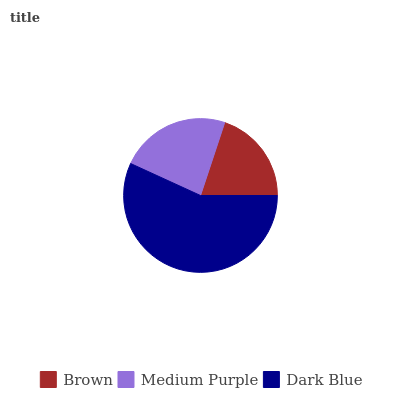Is Brown the minimum?
Answer yes or no. Yes. Is Dark Blue the maximum?
Answer yes or no. Yes. Is Medium Purple the minimum?
Answer yes or no. No. Is Medium Purple the maximum?
Answer yes or no. No. Is Medium Purple greater than Brown?
Answer yes or no. Yes. Is Brown less than Medium Purple?
Answer yes or no. Yes. Is Brown greater than Medium Purple?
Answer yes or no. No. Is Medium Purple less than Brown?
Answer yes or no. No. Is Medium Purple the high median?
Answer yes or no. Yes. Is Medium Purple the low median?
Answer yes or no. Yes. Is Dark Blue the high median?
Answer yes or no. No. Is Brown the low median?
Answer yes or no. No. 